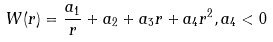Convert formula to latex. <formula><loc_0><loc_0><loc_500><loc_500>W ( r ) = \frac { a _ { 1 } } { r } + a _ { 2 } + a _ { 3 } r + a _ { 4 } r ^ { 2 } , a _ { 4 } < 0</formula> 